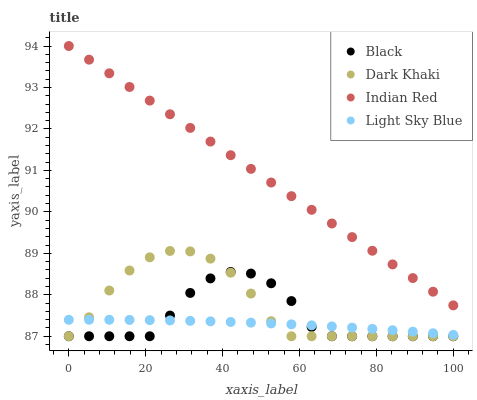Does Light Sky Blue have the minimum area under the curve?
Answer yes or no. Yes. Does Indian Red have the maximum area under the curve?
Answer yes or no. Yes. Does Black have the minimum area under the curve?
Answer yes or no. No. Does Black have the maximum area under the curve?
Answer yes or no. No. Is Indian Red the smoothest?
Answer yes or no. Yes. Is Black the roughest?
Answer yes or no. Yes. Is Light Sky Blue the smoothest?
Answer yes or no. No. Is Light Sky Blue the roughest?
Answer yes or no. No. Does Dark Khaki have the lowest value?
Answer yes or no. Yes. Does Light Sky Blue have the lowest value?
Answer yes or no. No. Does Indian Red have the highest value?
Answer yes or no. Yes. Does Black have the highest value?
Answer yes or no. No. Is Dark Khaki less than Indian Red?
Answer yes or no. Yes. Is Indian Red greater than Light Sky Blue?
Answer yes or no. Yes. Does Black intersect Dark Khaki?
Answer yes or no. Yes. Is Black less than Dark Khaki?
Answer yes or no. No. Is Black greater than Dark Khaki?
Answer yes or no. No. Does Dark Khaki intersect Indian Red?
Answer yes or no. No. 